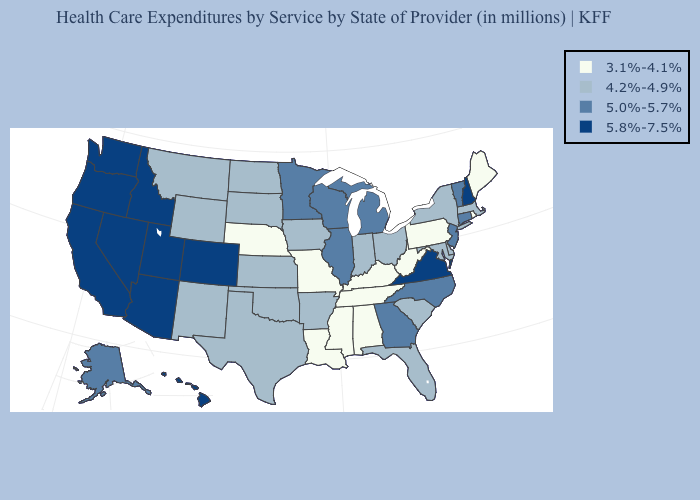Does Virginia have the highest value in the USA?
Keep it brief. Yes. What is the value of Utah?
Write a very short answer. 5.8%-7.5%. Does Rhode Island have the lowest value in the USA?
Give a very brief answer. Yes. Does Washington have the same value as Nevada?
Concise answer only. Yes. What is the lowest value in states that border North Dakota?
Be succinct. 4.2%-4.9%. Does Wisconsin have a lower value than Delaware?
Write a very short answer. No. Name the states that have a value in the range 3.1%-4.1%?
Keep it brief. Alabama, Kentucky, Louisiana, Maine, Mississippi, Missouri, Nebraska, Pennsylvania, Rhode Island, Tennessee, West Virginia. Does Oregon have the highest value in the USA?
Concise answer only. Yes. Does Washington have a higher value than Utah?
Write a very short answer. No. Name the states that have a value in the range 3.1%-4.1%?
Give a very brief answer. Alabama, Kentucky, Louisiana, Maine, Mississippi, Missouri, Nebraska, Pennsylvania, Rhode Island, Tennessee, West Virginia. Does North Carolina have the lowest value in the USA?
Give a very brief answer. No. Does the map have missing data?
Be succinct. No. What is the value of Iowa?
Write a very short answer. 4.2%-4.9%. Name the states that have a value in the range 5.0%-5.7%?
Answer briefly. Alaska, Connecticut, Georgia, Illinois, Michigan, Minnesota, New Jersey, North Carolina, Vermont, Wisconsin. 